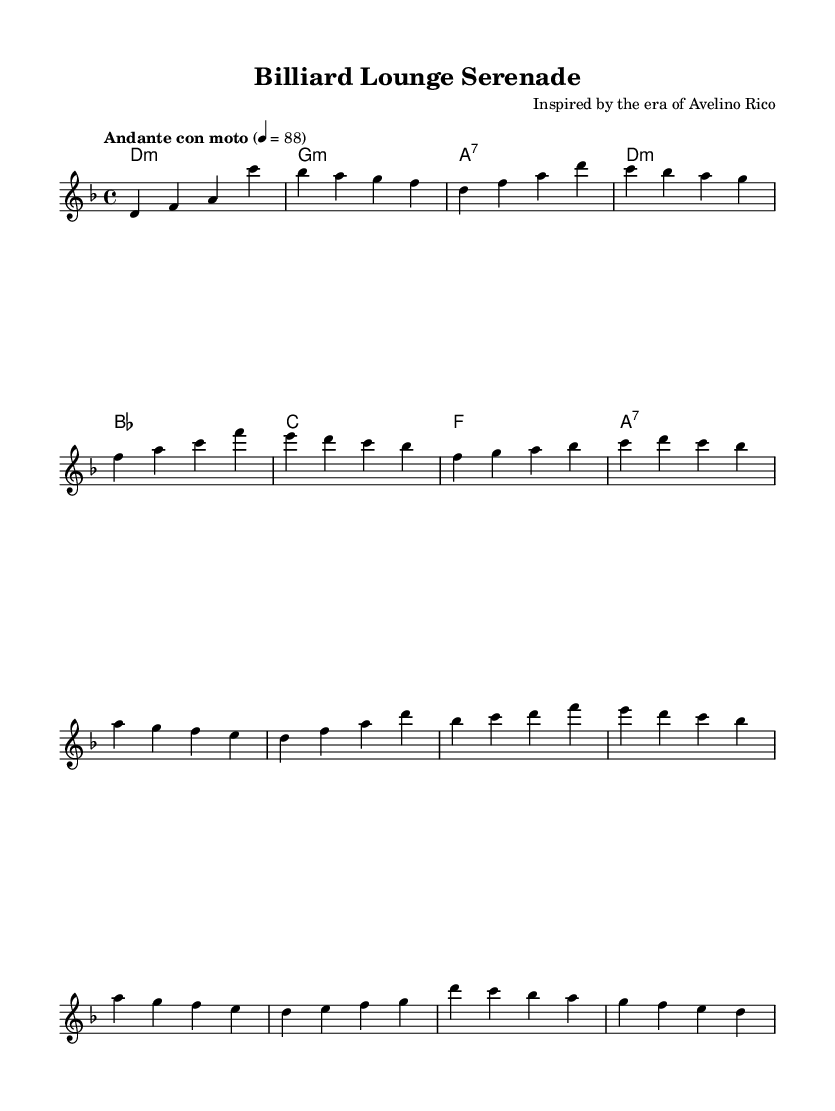What is the key signature of this music? The key signature is D minor, which has one flat (B flat). This can be identified from the key signature at the beginning of the staff.
Answer: D minor What is the time signature of this music? The time signature is 4/4, also known as common time. This can be seen in the beginning of the music, indicating four beats per measure.
Answer: 4/4 What is the tempo marking of this piece? The tempo marking is "Andante con moto," indicating a moderately walking pace with some motion. This is clearly stated above the staff.
Answer: Andante con moto How many measures are in the chorus section? The chorus consists of four measures, which can be counted directly in the notation for that section labeled within the score.
Answer: 4 Which chord is played for the intro? The chord played for the intro is D minor. This can be seen at the beginning of the harmonic progression listed in the chord names section.
Answer: D minor What type of musical piece is this? This piece is a serenade, as indicated by the title "Billiard Lounge Serenade." A serenade typically has a light and relaxing character, suited for a lounge atmosphere.
Answer: Serenade What is the last note of the melody? The last note of the melody is D. This can be determined by looking at the final note in the melody part, which is positioned at the end of the piece.
Answer: D 